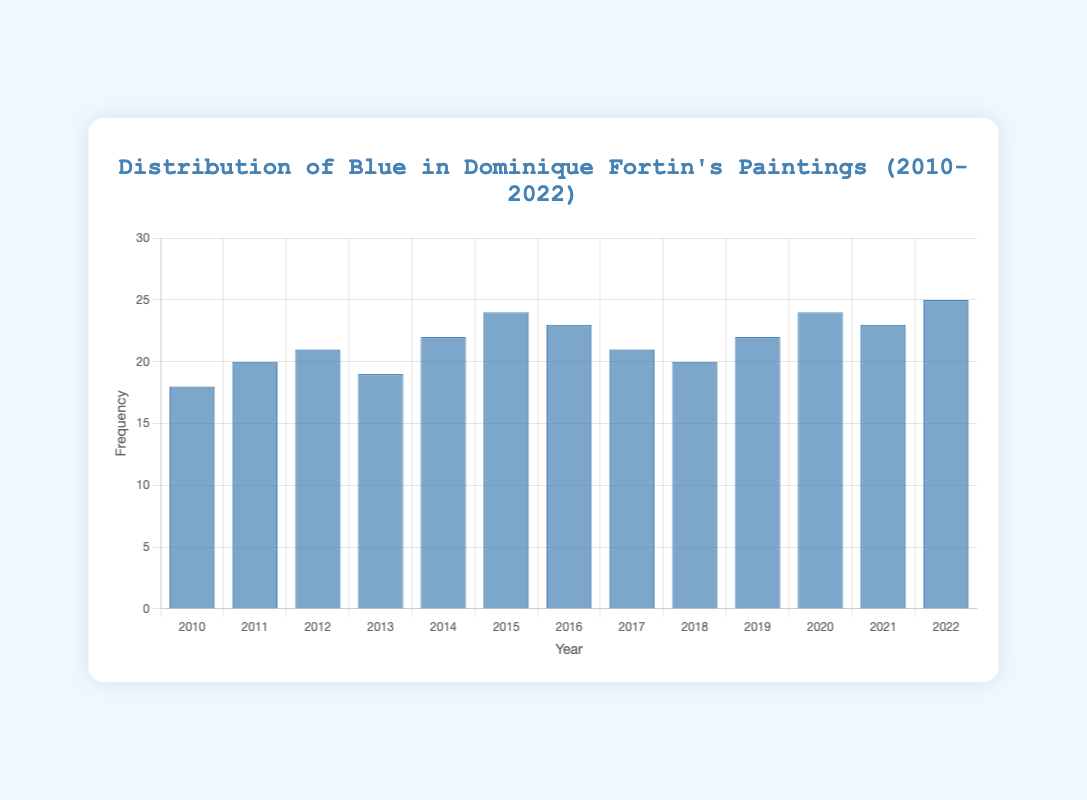How many times was blue used in 2020? We look at the bar corresponding to the year 2020 and check the height, which indicates the frequency. The value for 2020 is 24.
Answer: 24 Which year had the highest usage of blue? By examining the heights of all the bars, we identify that the year 2022 has the tallest bar, indicating the highest frequency of blue usage. The value is 25.
Answer: 2022 What is the average usage of blue over the years? To find the average, sum all the values for blue from 2010 to 2022: 18 + 20 + 21 + 19 + 22 + 24 + 23 + 21 + 20 + 22 + 24 + 23 + 25 = 282. Then, divide by the number of years, which is 13. So, the average usage is 282 / 13 ≈ 21.69.
Answer: 21.69 How does the usage of blue in 2015 compare to 2013? The height of the bar for 2015 is 24, whereas for 2013 it is 19. Therefore, blue was used more in 2015 than in 2013.
Answer: 2015 had higher usage By how much did the usage of blue increase from 2010 to 2022? Subtract the value of blue usage in 2010 from the value in 2022: 25 - 18 = 7.
Answer: 7 Which two consecutive years have the largest increase in the usage of blue? Calculate the difference for each pair of consecutive years: 2011-2010: 20-18 = 2, 2012-2011: 21-20 = 1, 2013-2012: 19-21 = -2, 2014-2013: 22-19 = 3, 2015-2014: 24-22 = 2, 2016-2015: 23-24 = -1, 2017-2016: 21-23 = -2, 2018-2017: 20-21 = -1, 2019-2018: 22-20 = 2, 2020-2019: 24-22 = 2, 2021-2020: 23-24 = -1, 2022-2021: 25-23 = 2. The largest increase is from 2014 to 2015, which is 3.
Answer: 2014 to 2015 Is there a year where the usage of blue is equal to 23? Look at the heights of the bars and identify the years where the value is 23: They are 2016, 2021, and 2022.
Answer: 2016, 2021, 2022 How often is the usage of blue above 20? Count the number of years where the value is greater than 20: 2012, 2014, 2015, 2016, 2019, 2020, 2021, 2022. There are 8 such years.
Answer: 8 Which year had the smallest usage of blue? By examining the heights of all the bars, we identify that the year 2010 has the shortest bar, indicating the smallest frequency of blue usage. The value is 18.
Answer: 2010 